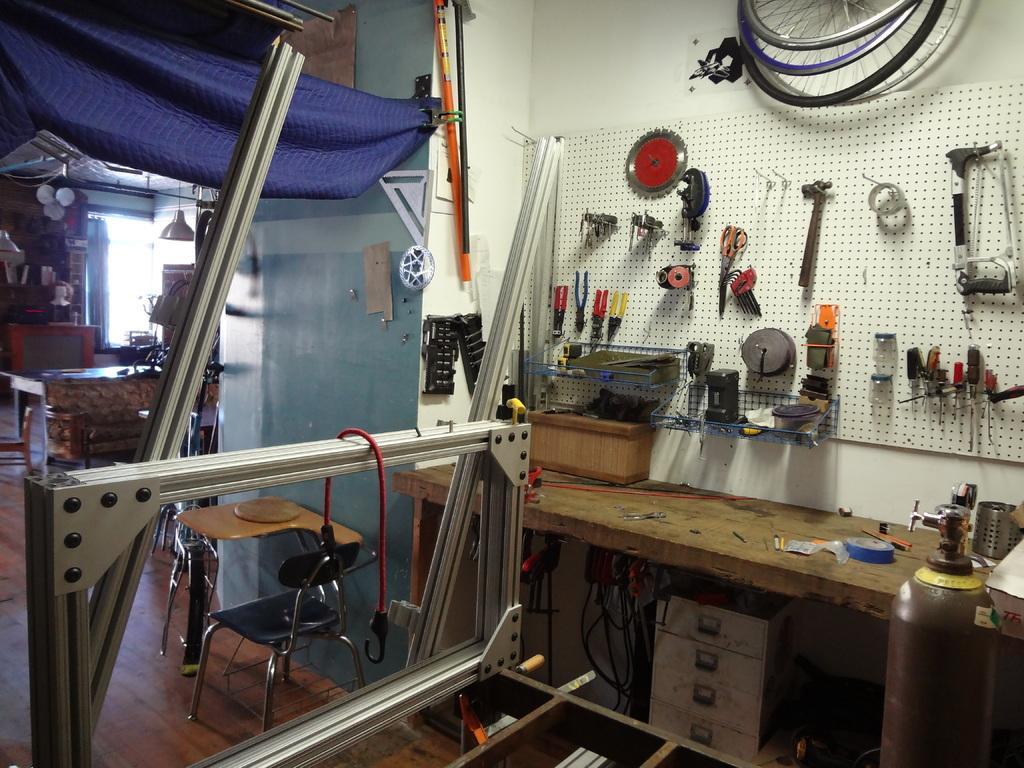How would you summarize this image in a sentence or two? In the picture we can see inside view of the mechanic shop with some tools which are placed on the board to the wall and on top of it, we can see some bicycle rims and near to the wall we can see a table with something are placed on it and beside it, we can see a steel frame and under the table we can see some draws and beside it we can see some things are placed and to the ceiling we can see a lamp is hanged. 